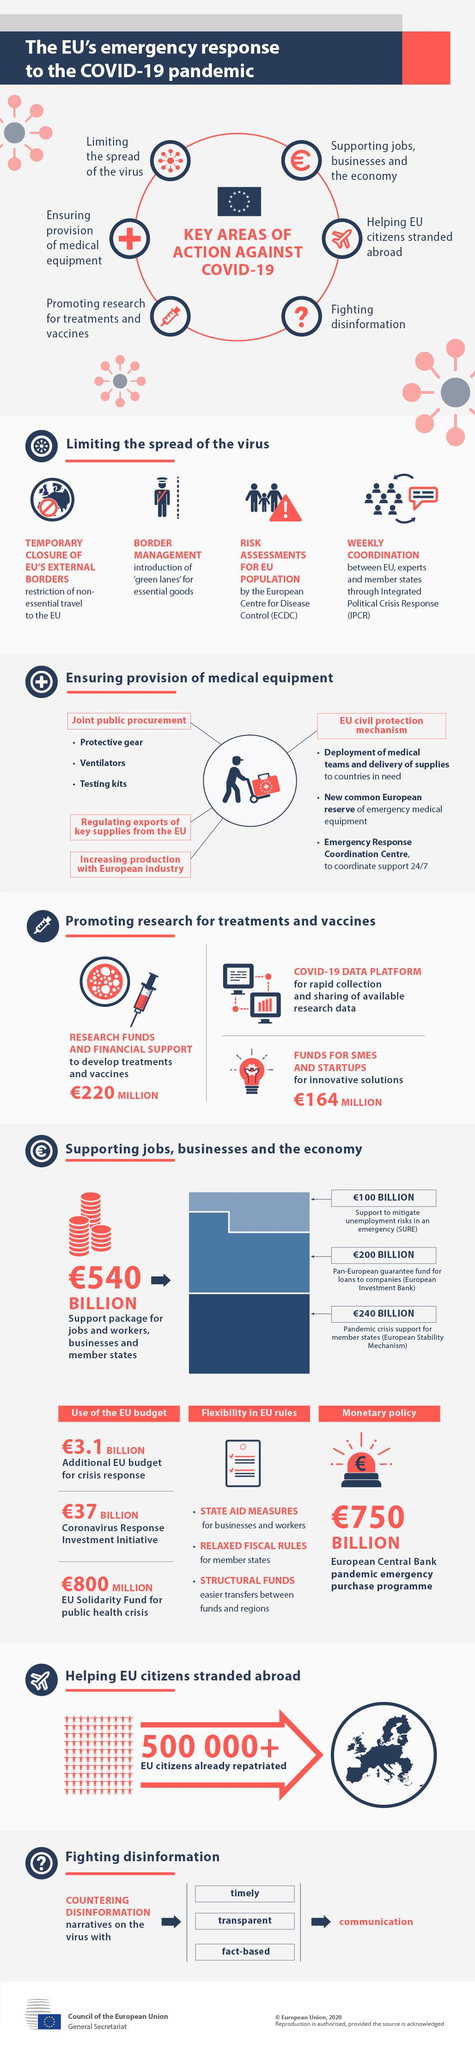Identify some key points in this picture. The European Union has granted 220 million euros to fund research aimed at developing treatments and vaccines for the COVID-19 virus. The European Union has granted 164 million euros to support the creation of innovative solutions by small and medium-sized enterprises and startups. It is estimated that over half a million EU citizens were brought back to the country after becoming stranded abroad. 